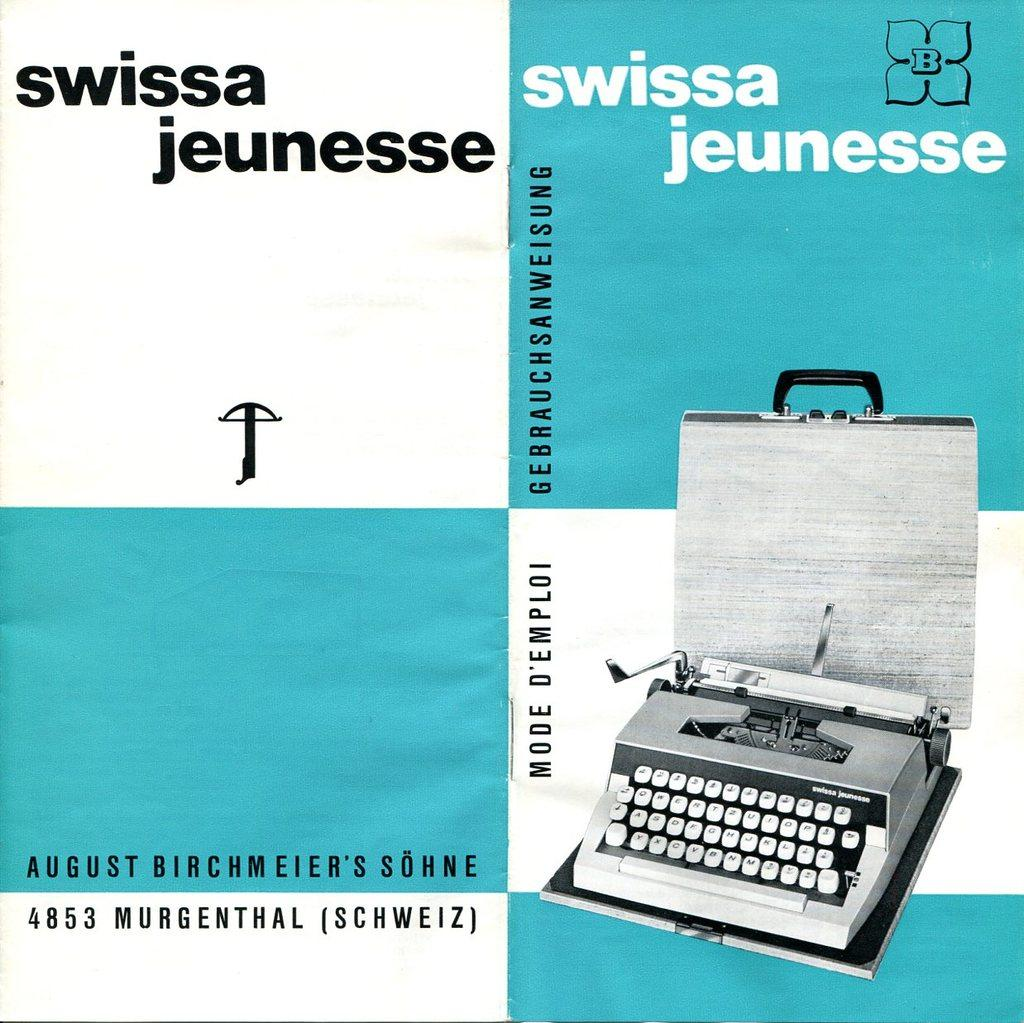Provide a one-sentence caption for the provided image. A picture for Swissa Jeunesse branded typewriter in white and blure. 